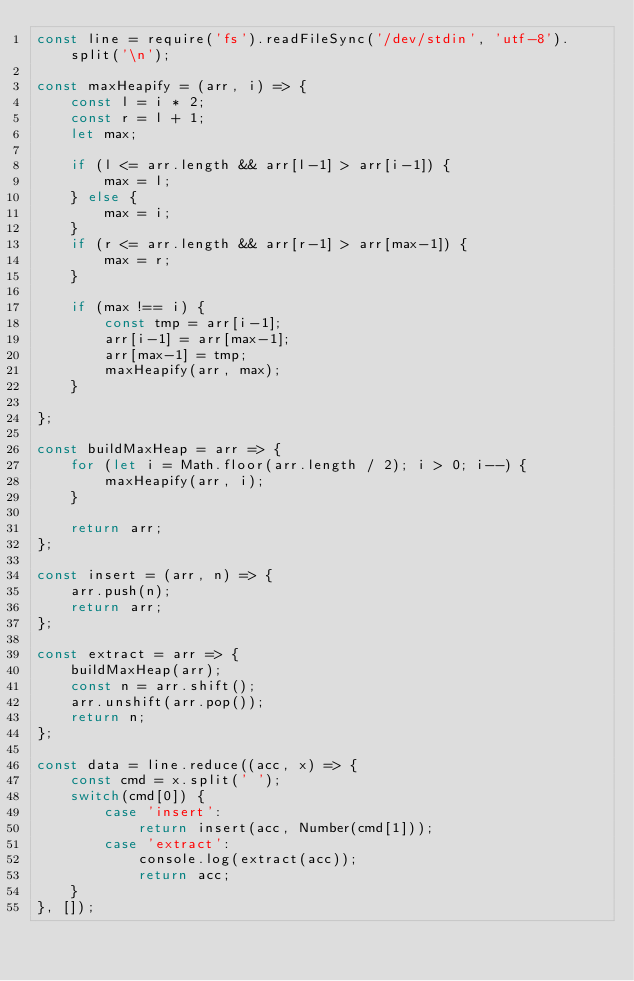Convert code to text. <code><loc_0><loc_0><loc_500><loc_500><_JavaScript_>const line = require('fs').readFileSync('/dev/stdin', 'utf-8').split('\n');

const maxHeapify = (arr, i) => {
    const l = i * 2;
    const r = l + 1;
    let max;

    if (l <= arr.length && arr[l-1] > arr[i-1]) {
        max = l;
    } else {
        max = i;
    }
    if (r <= arr.length && arr[r-1] > arr[max-1]) {
        max = r;
    }

    if (max !== i) {
        const tmp = arr[i-1];
        arr[i-1] = arr[max-1];
        arr[max-1] = tmp;
        maxHeapify(arr, max);
    }

};

const buildMaxHeap = arr => {
    for (let i = Math.floor(arr.length / 2); i > 0; i--) {
        maxHeapify(arr, i);
    }

    return arr;
};

const insert = (arr, n) => {
    arr.push(n);
    return arr;
};

const extract = arr => {
    buildMaxHeap(arr);
    const n = arr.shift();
    arr.unshift(arr.pop());
    return n;
};

const data = line.reduce((acc, x) => {
    const cmd = x.split(' ');
    switch(cmd[0]) {
        case 'insert':
            return insert(acc, Number(cmd[1]));
        case 'extract':
            console.log(extract(acc));
            return acc;
    }
}, []);

</code> 